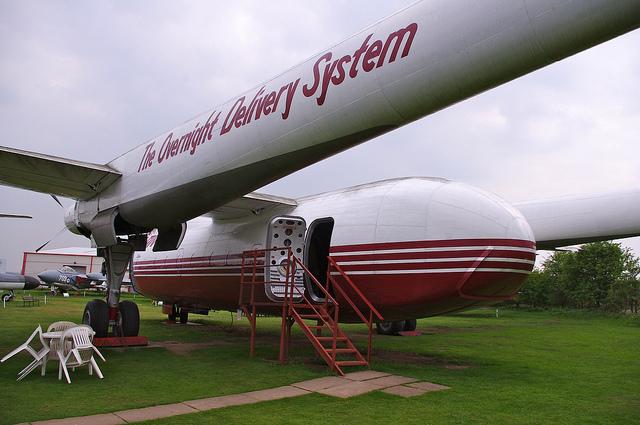Is the plane in the air?
Give a very brief answer. No. Where is the plane?
Concise answer only. On grass. What furniture is under the plane?
Quick response, please. Chairs. 